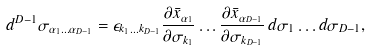<formula> <loc_0><loc_0><loc_500><loc_500>d ^ { D - 1 } \sigma _ { \alpha _ { 1 } \dots \alpha _ { D - 1 } } = \epsilon _ { k _ { 1 } \dots k _ { D - 1 } } \frac { \partial \bar { x } _ { \alpha _ { 1 } } } { \partial \sigma _ { k _ { 1 } } } \dots \frac { \partial \bar { x } _ { \alpha _ { D - 1 } } } { \partial \sigma _ { k _ { D - 1 } } } \, d \sigma _ { 1 } \dots d \sigma _ { D - 1 } ,</formula> 